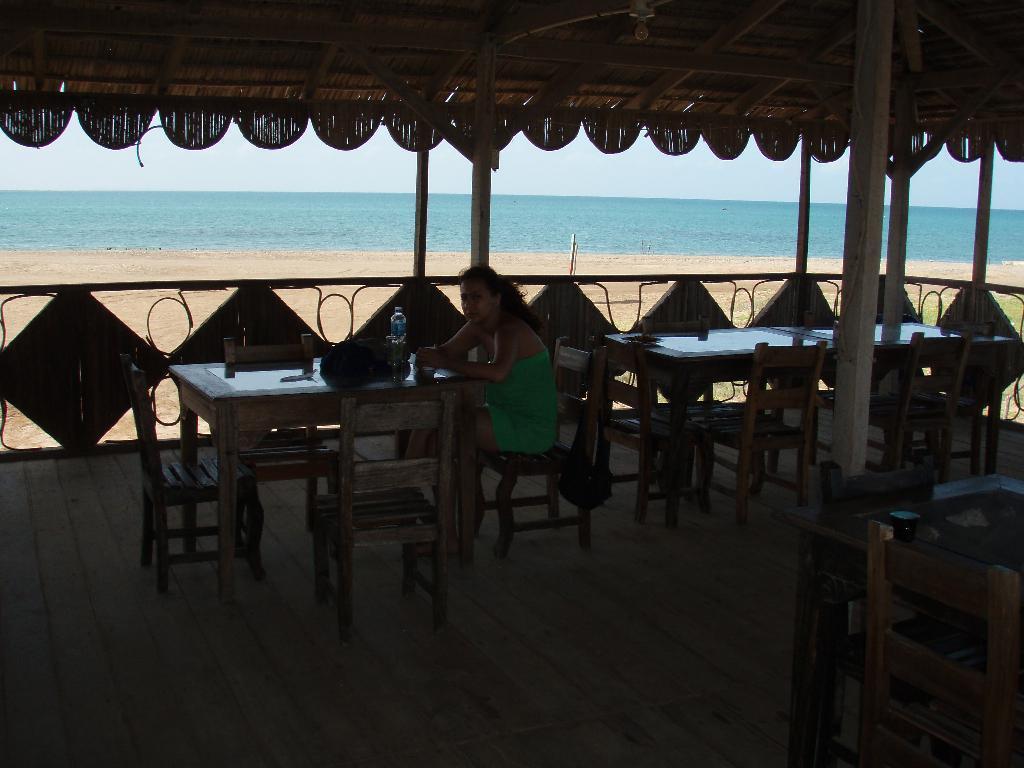Please provide a concise description of this image. In this picture, we see a woman is sitting on the chair. In front of her, we see a table on which a water bottle and a bag are placed. Behind her, we see the chairs and the tables. At the top, we see the roof of the shed. In the middle, we see the sand. In the background, we see a water body and the sky. 